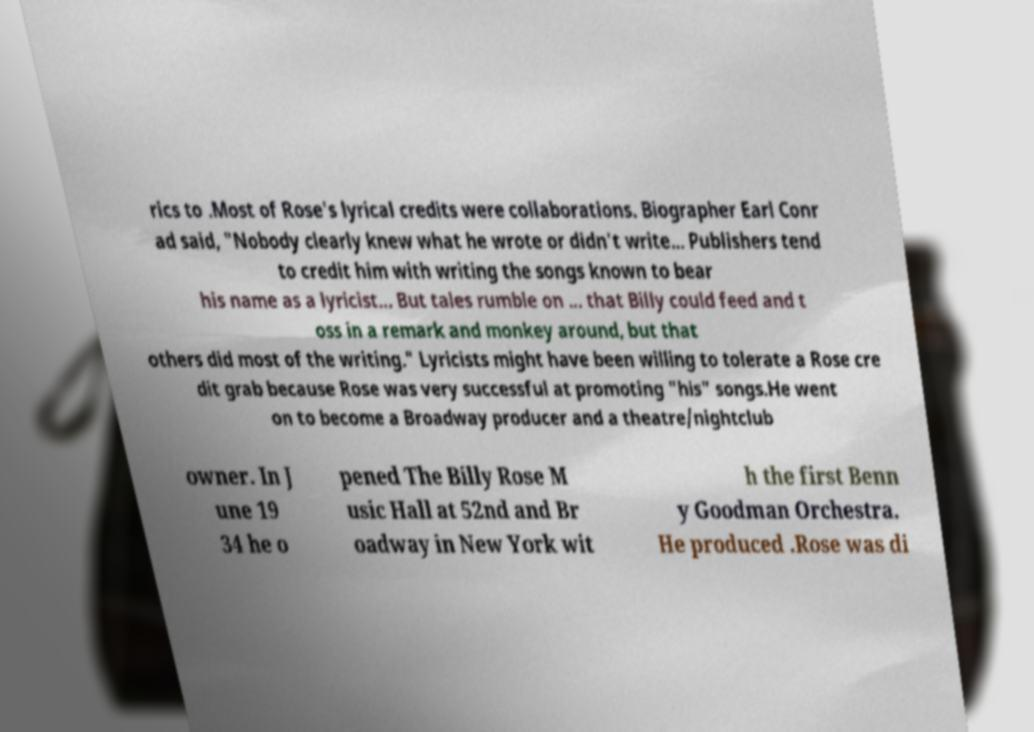Could you extract and type out the text from this image? rics to .Most of Rose's lyrical credits were collaborations. Biographer Earl Conr ad said, "Nobody clearly knew what he wrote or didn't write... Publishers tend to credit him with writing the songs known to bear his name as a lyricist... But tales rumble on ... that Billy could feed and t oss in a remark and monkey around, but that others did most of the writing." Lyricists might have been willing to tolerate a Rose cre dit grab because Rose was very successful at promoting "his" songs.He went on to become a Broadway producer and a theatre/nightclub owner. In J une 19 34 he o pened The Billy Rose M usic Hall at 52nd and Br oadway in New York wit h the first Benn y Goodman Orchestra. He produced .Rose was di 